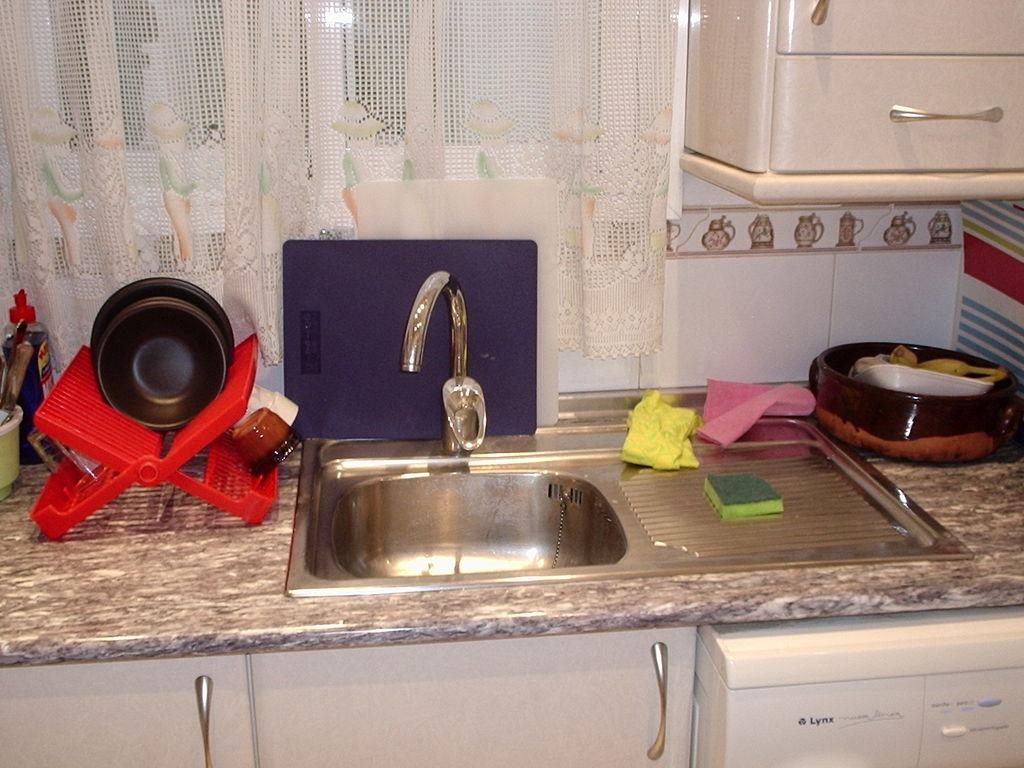<image>
Present a compact description of the photo's key features. the word Lynx is on some kind of dishwasher 